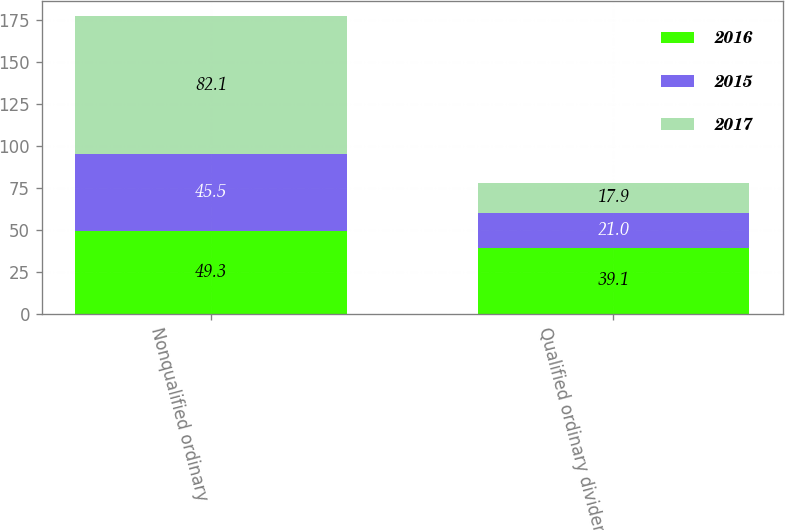Convert chart. <chart><loc_0><loc_0><loc_500><loc_500><stacked_bar_chart><ecel><fcel>Nonqualified ordinary<fcel>Qualified ordinary dividends<nl><fcel>2016<fcel>49.3<fcel>39.1<nl><fcel>2015<fcel>45.5<fcel>21<nl><fcel>2017<fcel>82.1<fcel>17.9<nl></chart> 